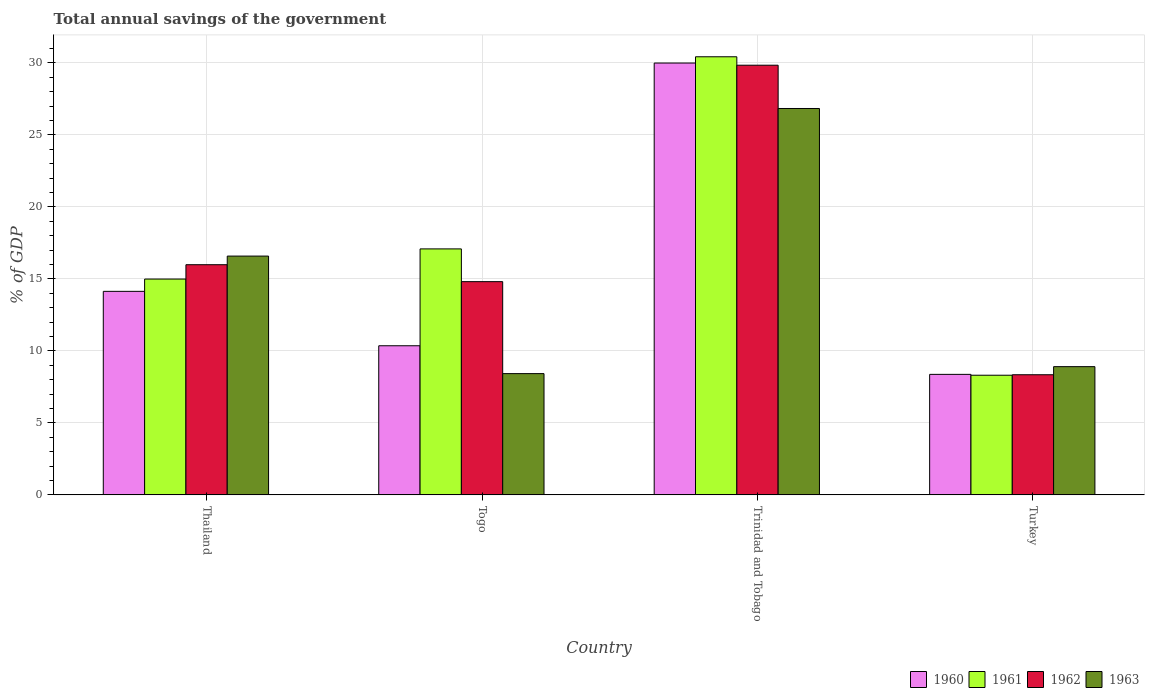How many groups of bars are there?
Your response must be concise. 4. Are the number of bars on each tick of the X-axis equal?
Your response must be concise. Yes. How many bars are there on the 1st tick from the left?
Your answer should be very brief. 4. What is the label of the 1st group of bars from the left?
Provide a short and direct response. Thailand. What is the total annual savings of the government in 1961 in Thailand?
Your answer should be very brief. 14.99. Across all countries, what is the maximum total annual savings of the government in 1963?
Provide a short and direct response. 26.83. Across all countries, what is the minimum total annual savings of the government in 1960?
Offer a very short reply. 8.37. In which country was the total annual savings of the government in 1963 maximum?
Provide a short and direct response. Trinidad and Tobago. What is the total total annual savings of the government in 1962 in the graph?
Provide a succinct answer. 68.98. What is the difference between the total annual savings of the government in 1961 in Thailand and that in Togo?
Your answer should be very brief. -2.09. What is the difference between the total annual savings of the government in 1963 in Togo and the total annual savings of the government in 1961 in Turkey?
Provide a short and direct response. 0.11. What is the average total annual savings of the government in 1963 per country?
Keep it short and to the point. 15.19. What is the difference between the total annual savings of the government of/in 1961 and total annual savings of the government of/in 1962 in Thailand?
Ensure brevity in your answer.  -1. What is the ratio of the total annual savings of the government in 1960 in Trinidad and Tobago to that in Turkey?
Offer a terse response. 3.58. Is the total annual savings of the government in 1961 in Togo less than that in Turkey?
Your response must be concise. No. Is the difference between the total annual savings of the government in 1961 in Thailand and Trinidad and Tobago greater than the difference between the total annual savings of the government in 1962 in Thailand and Trinidad and Tobago?
Give a very brief answer. No. What is the difference between the highest and the second highest total annual savings of the government in 1960?
Your response must be concise. -19.63. What is the difference between the highest and the lowest total annual savings of the government in 1960?
Provide a succinct answer. 21.62. In how many countries, is the total annual savings of the government in 1963 greater than the average total annual savings of the government in 1963 taken over all countries?
Offer a terse response. 2. Is it the case that in every country, the sum of the total annual savings of the government in 1960 and total annual savings of the government in 1961 is greater than the sum of total annual savings of the government in 1963 and total annual savings of the government in 1962?
Provide a short and direct response. No. What does the 1st bar from the right in Turkey represents?
Ensure brevity in your answer.  1963. What is the difference between two consecutive major ticks on the Y-axis?
Make the answer very short. 5. Are the values on the major ticks of Y-axis written in scientific E-notation?
Keep it short and to the point. No. Where does the legend appear in the graph?
Provide a succinct answer. Bottom right. How are the legend labels stacked?
Provide a succinct answer. Horizontal. What is the title of the graph?
Your answer should be very brief. Total annual savings of the government. Does "2000" appear as one of the legend labels in the graph?
Give a very brief answer. No. What is the label or title of the X-axis?
Offer a very short reply. Country. What is the label or title of the Y-axis?
Give a very brief answer. % of GDP. What is the % of GDP in 1960 in Thailand?
Your answer should be very brief. 14.13. What is the % of GDP of 1961 in Thailand?
Your response must be concise. 14.99. What is the % of GDP of 1962 in Thailand?
Your response must be concise. 15.99. What is the % of GDP of 1963 in Thailand?
Provide a succinct answer. 16.58. What is the % of GDP of 1960 in Togo?
Ensure brevity in your answer.  10.36. What is the % of GDP of 1961 in Togo?
Your response must be concise. 17.08. What is the % of GDP in 1962 in Togo?
Provide a short and direct response. 14.81. What is the % of GDP in 1963 in Togo?
Offer a terse response. 8.42. What is the % of GDP in 1960 in Trinidad and Tobago?
Make the answer very short. 29.99. What is the % of GDP of 1961 in Trinidad and Tobago?
Your answer should be very brief. 30.42. What is the % of GDP of 1962 in Trinidad and Tobago?
Offer a very short reply. 29.84. What is the % of GDP of 1963 in Trinidad and Tobago?
Your answer should be very brief. 26.83. What is the % of GDP of 1960 in Turkey?
Offer a very short reply. 8.37. What is the % of GDP in 1961 in Turkey?
Ensure brevity in your answer.  8.31. What is the % of GDP of 1962 in Turkey?
Provide a short and direct response. 8.34. What is the % of GDP in 1963 in Turkey?
Make the answer very short. 8.91. Across all countries, what is the maximum % of GDP of 1960?
Offer a very short reply. 29.99. Across all countries, what is the maximum % of GDP in 1961?
Give a very brief answer. 30.42. Across all countries, what is the maximum % of GDP in 1962?
Provide a short and direct response. 29.84. Across all countries, what is the maximum % of GDP of 1963?
Offer a very short reply. 26.83. Across all countries, what is the minimum % of GDP of 1960?
Make the answer very short. 8.37. Across all countries, what is the minimum % of GDP in 1961?
Give a very brief answer. 8.31. Across all countries, what is the minimum % of GDP in 1962?
Provide a succinct answer. 8.34. Across all countries, what is the minimum % of GDP in 1963?
Offer a very short reply. 8.42. What is the total % of GDP of 1960 in the graph?
Offer a terse response. 62.85. What is the total % of GDP in 1961 in the graph?
Provide a succinct answer. 70.81. What is the total % of GDP of 1962 in the graph?
Ensure brevity in your answer.  68.98. What is the total % of GDP of 1963 in the graph?
Provide a short and direct response. 60.75. What is the difference between the % of GDP of 1960 in Thailand and that in Togo?
Keep it short and to the point. 3.78. What is the difference between the % of GDP in 1961 in Thailand and that in Togo?
Provide a succinct answer. -2.09. What is the difference between the % of GDP of 1962 in Thailand and that in Togo?
Provide a succinct answer. 1.18. What is the difference between the % of GDP of 1963 in Thailand and that in Togo?
Offer a terse response. 8.16. What is the difference between the % of GDP in 1960 in Thailand and that in Trinidad and Tobago?
Your response must be concise. -15.86. What is the difference between the % of GDP of 1961 in Thailand and that in Trinidad and Tobago?
Your answer should be compact. -15.44. What is the difference between the % of GDP in 1962 in Thailand and that in Trinidad and Tobago?
Provide a short and direct response. -13.85. What is the difference between the % of GDP of 1963 in Thailand and that in Trinidad and Tobago?
Make the answer very short. -10.25. What is the difference between the % of GDP in 1960 in Thailand and that in Turkey?
Your answer should be compact. 5.76. What is the difference between the % of GDP of 1961 in Thailand and that in Turkey?
Give a very brief answer. 6.68. What is the difference between the % of GDP in 1962 in Thailand and that in Turkey?
Give a very brief answer. 7.64. What is the difference between the % of GDP in 1963 in Thailand and that in Turkey?
Offer a terse response. 7.68. What is the difference between the % of GDP of 1960 in Togo and that in Trinidad and Tobago?
Ensure brevity in your answer.  -19.63. What is the difference between the % of GDP of 1961 in Togo and that in Trinidad and Tobago?
Offer a very short reply. -13.34. What is the difference between the % of GDP in 1962 in Togo and that in Trinidad and Tobago?
Offer a terse response. -15.03. What is the difference between the % of GDP in 1963 in Togo and that in Trinidad and Tobago?
Ensure brevity in your answer.  -18.41. What is the difference between the % of GDP of 1960 in Togo and that in Turkey?
Provide a succinct answer. 1.99. What is the difference between the % of GDP in 1961 in Togo and that in Turkey?
Your answer should be compact. 8.77. What is the difference between the % of GDP in 1962 in Togo and that in Turkey?
Make the answer very short. 6.46. What is the difference between the % of GDP of 1963 in Togo and that in Turkey?
Provide a succinct answer. -0.48. What is the difference between the % of GDP of 1960 in Trinidad and Tobago and that in Turkey?
Your response must be concise. 21.62. What is the difference between the % of GDP of 1961 in Trinidad and Tobago and that in Turkey?
Provide a succinct answer. 22.11. What is the difference between the % of GDP of 1962 in Trinidad and Tobago and that in Turkey?
Your answer should be compact. 21.5. What is the difference between the % of GDP of 1963 in Trinidad and Tobago and that in Turkey?
Offer a very short reply. 17.93. What is the difference between the % of GDP in 1960 in Thailand and the % of GDP in 1961 in Togo?
Offer a very short reply. -2.95. What is the difference between the % of GDP in 1960 in Thailand and the % of GDP in 1962 in Togo?
Offer a terse response. -0.67. What is the difference between the % of GDP of 1960 in Thailand and the % of GDP of 1963 in Togo?
Keep it short and to the point. 5.71. What is the difference between the % of GDP in 1961 in Thailand and the % of GDP in 1962 in Togo?
Ensure brevity in your answer.  0.18. What is the difference between the % of GDP in 1961 in Thailand and the % of GDP in 1963 in Togo?
Provide a succinct answer. 6.57. What is the difference between the % of GDP of 1962 in Thailand and the % of GDP of 1963 in Togo?
Offer a very short reply. 7.56. What is the difference between the % of GDP in 1960 in Thailand and the % of GDP in 1961 in Trinidad and Tobago?
Your answer should be very brief. -16.29. What is the difference between the % of GDP in 1960 in Thailand and the % of GDP in 1962 in Trinidad and Tobago?
Give a very brief answer. -15.7. What is the difference between the % of GDP of 1960 in Thailand and the % of GDP of 1963 in Trinidad and Tobago?
Offer a terse response. -12.7. What is the difference between the % of GDP in 1961 in Thailand and the % of GDP in 1962 in Trinidad and Tobago?
Provide a succinct answer. -14.85. What is the difference between the % of GDP in 1961 in Thailand and the % of GDP in 1963 in Trinidad and Tobago?
Your response must be concise. -11.85. What is the difference between the % of GDP of 1962 in Thailand and the % of GDP of 1963 in Trinidad and Tobago?
Keep it short and to the point. -10.85. What is the difference between the % of GDP in 1960 in Thailand and the % of GDP in 1961 in Turkey?
Your response must be concise. 5.82. What is the difference between the % of GDP of 1960 in Thailand and the % of GDP of 1962 in Turkey?
Make the answer very short. 5.79. What is the difference between the % of GDP in 1960 in Thailand and the % of GDP in 1963 in Turkey?
Offer a terse response. 5.23. What is the difference between the % of GDP of 1961 in Thailand and the % of GDP of 1962 in Turkey?
Your response must be concise. 6.65. What is the difference between the % of GDP of 1961 in Thailand and the % of GDP of 1963 in Turkey?
Your answer should be compact. 6.08. What is the difference between the % of GDP in 1962 in Thailand and the % of GDP in 1963 in Turkey?
Ensure brevity in your answer.  7.08. What is the difference between the % of GDP of 1960 in Togo and the % of GDP of 1961 in Trinidad and Tobago?
Give a very brief answer. -20.07. What is the difference between the % of GDP in 1960 in Togo and the % of GDP in 1962 in Trinidad and Tobago?
Your answer should be compact. -19.48. What is the difference between the % of GDP of 1960 in Togo and the % of GDP of 1963 in Trinidad and Tobago?
Offer a terse response. -16.48. What is the difference between the % of GDP of 1961 in Togo and the % of GDP of 1962 in Trinidad and Tobago?
Your answer should be very brief. -12.76. What is the difference between the % of GDP in 1961 in Togo and the % of GDP in 1963 in Trinidad and Tobago?
Offer a terse response. -9.75. What is the difference between the % of GDP in 1962 in Togo and the % of GDP in 1963 in Trinidad and Tobago?
Make the answer very short. -12.03. What is the difference between the % of GDP in 1960 in Togo and the % of GDP in 1961 in Turkey?
Give a very brief answer. 2.05. What is the difference between the % of GDP of 1960 in Togo and the % of GDP of 1962 in Turkey?
Your answer should be compact. 2.01. What is the difference between the % of GDP of 1960 in Togo and the % of GDP of 1963 in Turkey?
Give a very brief answer. 1.45. What is the difference between the % of GDP in 1961 in Togo and the % of GDP in 1962 in Turkey?
Your answer should be very brief. 8.74. What is the difference between the % of GDP in 1961 in Togo and the % of GDP in 1963 in Turkey?
Your response must be concise. 8.18. What is the difference between the % of GDP in 1962 in Togo and the % of GDP in 1963 in Turkey?
Offer a very short reply. 5.9. What is the difference between the % of GDP in 1960 in Trinidad and Tobago and the % of GDP in 1961 in Turkey?
Make the answer very short. 21.68. What is the difference between the % of GDP in 1960 in Trinidad and Tobago and the % of GDP in 1962 in Turkey?
Give a very brief answer. 21.65. What is the difference between the % of GDP in 1960 in Trinidad and Tobago and the % of GDP in 1963 in Turkey?
Keep it short and to the point. 21.08. What is the difference between the % of GDP in 1961 in Trinidad and Tobago and the % of GDP in 1962 in Turkey?
Ensure brevity in your answer.  22.08. What is the difference between the % of GDP in 1961 in Trinidad and Tobago and the % of GDP in 1963 in Turkey?
Offer a very short reply. 21.52. What is the difference between the % of GDP of 1962 in Trinidad and Tobago and the % of GDP of 1963 in Turkey?
Give a very brief answer. 20.93. What is the average % of GDP in 1960 per country?
Keep it short and to the point. 15.71. What is the average % of GDP of 1961 per country?
Your answer should be compact. 17.7. What is the average % of GDP in 1962 per country?
Offer a terse response. 17.24. What is the average % of GDP of 1963 per country?
Your response must be concise. 15.19. What is the difference between the % of GDP in 1960 and % of GDP in 1961 in Thailand?
Keep it short and to the point. -0.85. What is the difference between the % of GDP of 1960 and % of GDP of 1962 in Thailand?
Provide a succinct answer. -1.85. What is the difference between the % of GDP of 1960 and % of GDP of 1963 in Thailand?
Your response must be concise. -2.45. What is the difference between the % of GDP of 1961 and % of GDP of 1962 in Thailand?
Offer a very short reply. -1. What is the difference between the % of GDP of 1961 and % of GDP of 1963 in Thailand?
Keep it short and to the point. -1.59. What is the difference between the % of GDP of 1962 and % of GDP of 1963 in Thailand?
Ensure brevity in your answer.  -0.6. What is the difference between the % of GDP in 1960 and % of GDP in 1961 in Togo?
Provide a short and direct response. -6.73. What is the difference between the % of GDP of 1960 and % of GDP of 1962 in Togo?
Your response must be concise. -4.45. What is the difference between the % of GDP of 1960 and % of GDP of 1963 in Togo?
Your answer should be very brief. 1.93. What is the difference between the % of GDP of 1961 and % of GDP of 1962 in Togo?
Offer a very short reply. 2.27. What is the difference between the % of GDP of 1961 and % of GDP of 1963 in Togo?
Provide a short and direct response. 8.66. What is the difference between the % of GDP of 1962 and % of GDP of 1963 in Togo?
Offer a terse response. 6.39. What is the difference between the % of GDP in 1960 and % of GDP in 1961 in Trinidad and Tobago?
Give a very brief answer. -0.43. What is the difference between the % of GDP in 1960 and % of GDP in 1962 in Trinidad and Tobago?
Your response must be concise. 0.15. What is the difference between the % of GDP in 1960 and % of GDP in 1963 in Trinidad and Tobago?
Provide a short and direct response. 3.16. What is the difference between the % of GDP of 1961 and % of GDP of 1962 in Trinidad and Tobago?
Your answer should be compact. 0.59. What is the difference between the % of GDP in 1961 and % of GDP in 1963 in Trinidad and Tobago?
Make the answer very short. 3.59. What is the difference between the % of GDP of 1962 and % of GDP of 1963 in Trinidad and Tobago?
Keep it short and to the point. 3. What is the difference between the % of GDP in 1960 and % of GDP in 1961 in Turkey?
Offer a very short reply. 0.06. What is the difference between the % of GDP in 1960 and % of GDP in 1962 in Turkey?
Offer a very short reply. 0.03. What is the difference between the % of GDP of 1960 and % of GDP of 1963 in Turkey?
Your answer should be very brief. -0.54. What is the difference between the % of GDP of 1961 and % of GDP of 1962 in Turkey?
Your answer should be compact. -0.03. What is the difference between the % of GDP of 1961 and % of GDP of 1963 in Turkey?
Ensure brevity in your answer.  -0.6. What is the difference between the % of GDP in 1962 and % of GDP in 1963 in Turkey?
Your response must be concise. -0.56. What is the ratio of the % of GDP of 1960 in Thailand to that in Togo?
Offer a very short reply. 1.36. What is the ratio of the % of GDP of 1961 in Thailand to that in Togo?
Provide a succinct answer. 0.88. What is the ratio of the % of GDP in 1962 in Thailand to that in Togo?
Ensure brevity in your answer.  1.08. What is the ratio of the % of GDP in 1963 in Thailand to that in Togo?
Provide a succinct answer. 1.97. What is the ratio of the % of GDP of 1960 in Thailand to that in Trinidad and Tobago?
Your answer should be compact. 0.47. What is the ratio of the % of GDP of 1961 in Thailand to that in Trinidad and Tobago?
Your answer should be very brief. 0.49. What is the ratio of the % of GDP in 1962 in Thailand to that in Trinidad and Tobago?
Your answer should be very brief. 0.54. What is the ratio of the % of GDP of 1963 in Thailand to that in Trinidad and Tobago?
Your answer should be compact. 0.62. What is the ratio of the % of GDP in 1960 in Thailand to that in Turkey?
Provide a short and direct response. 1.69. What is the ratio of the % of GDP of 1961 in Thailand to that in Turkey?
Make the answer very short. 1.8. What is the ratio of the % of GDP of 1962 in Thailand to that in Turkey?
Keep it short and to the point. 1.92. What is the ratio of the % of GDP of 1963 in Thailand to that in Turkey?
Keep it short and to the point. 1.86. What is the ratio of the % of GDP in 1960 in Togo to that in Trinidad and Tobago?
Ensure brevity in your answer.  0.35. What is the ratio of the % of GDP of 1961 in Togo to that in Trinidad and Tobago?
Provide a short and direct response. 0.56. What is the ratio of the % of GDP in 1962 in Togo to that in Trinidad and Tobago?
Give a very brief answer. 0.5. What is the ratio of the % of GDP of 1963 in Togo to that in Trinidad and Tobago?
Offer a terse response. 0.31. What is the ratio of the % of GDP in 1960 in Togo to that in Turkey?
Your answer should be compact. 1.24. What is the ratio of the % of GDP in 1961 in Togo to that in Turkey?
Offer a very short reply. 2.06. What is the ratio of the % of GDP in 1962 in Togo to that in Turkey?
Ensure brevity in your answer.  1.77. What is the ratio of the % of GDP of 1963 in Togo to that in Turkey?
Offer a very short reply. 0.95. What is the ratio of the % of GDP in 1960 in Trinidad and Tobago to that in Turkey?
Your answer should be very brief. 3.58. What is the ratio of the % of GDP in 1961 in Trinidad and Tobago to that in Turkey?
Your answer should be compact. 3.66. What is the ratio of the % of GDP in 1962 in Trinidad and Tobago to that in Turkey?
Your response must be concise. 3.58. What is the ratio of the % of GDP of 1963 in Trinidad and Tobago to that in Turkey?
Ensure brevity in your answer.  3.01. What is the difference between the highest and the second highest % of GDP of 1960?
Offer a terse response. 15.86. What is the difference between the highest and the second highest % of GDP of 1961?
Ensure brevity in your answer.  13.34. What is the difference between the highest and the second highest % of GDP of 1962?
Your answer should be compact. 13.85. What is the difference between the highest and the second highest % of GDP in 1963?
Your answer should be very brief. 10.25. What is the difference between the highest and the lowest % of GDP of 1960?
Ensure brevity in your answer.  21.62. What is the difference between the highest and the lowest % of GDP of 1961?
Your answer should be compact. 22.11. What is the difference between the highest and the lowest % of GDP of 1962?
Your response must be concise. 21.5. What is the difference between the highest and the lowest % of GDP of 1963?
Make the answer very short. 18.41. 